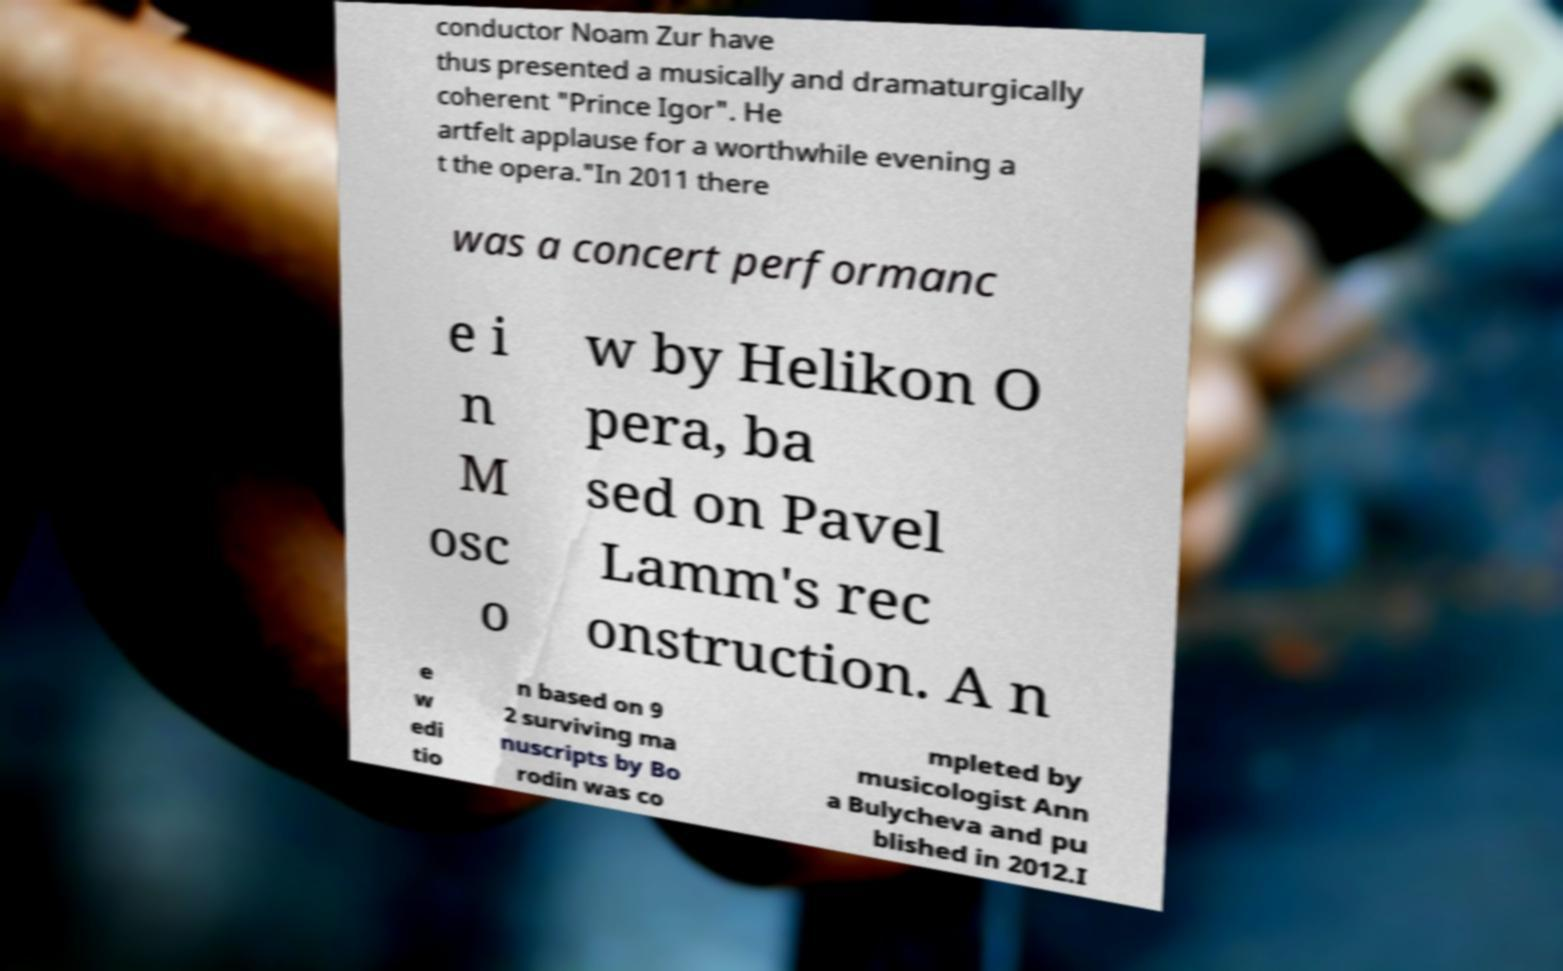Please identify and transcribe the text found in this image. conductor Noam Zur have thus presented a musically and dramaturgically coherent "Prince Igor". He artfelt applause for a worthwhile evening a t the opera."In 2011 there was a concert performanc e i n M osc o w by Helikon O pera, ba sed on Pavel Lamm's rec onstruction. A n e w edi tio n based on 9 2 surviving ma nuscripts by Bo rodin was co mpleted by musicologist Ann a Bulycheva and pu blished in 2012.I 